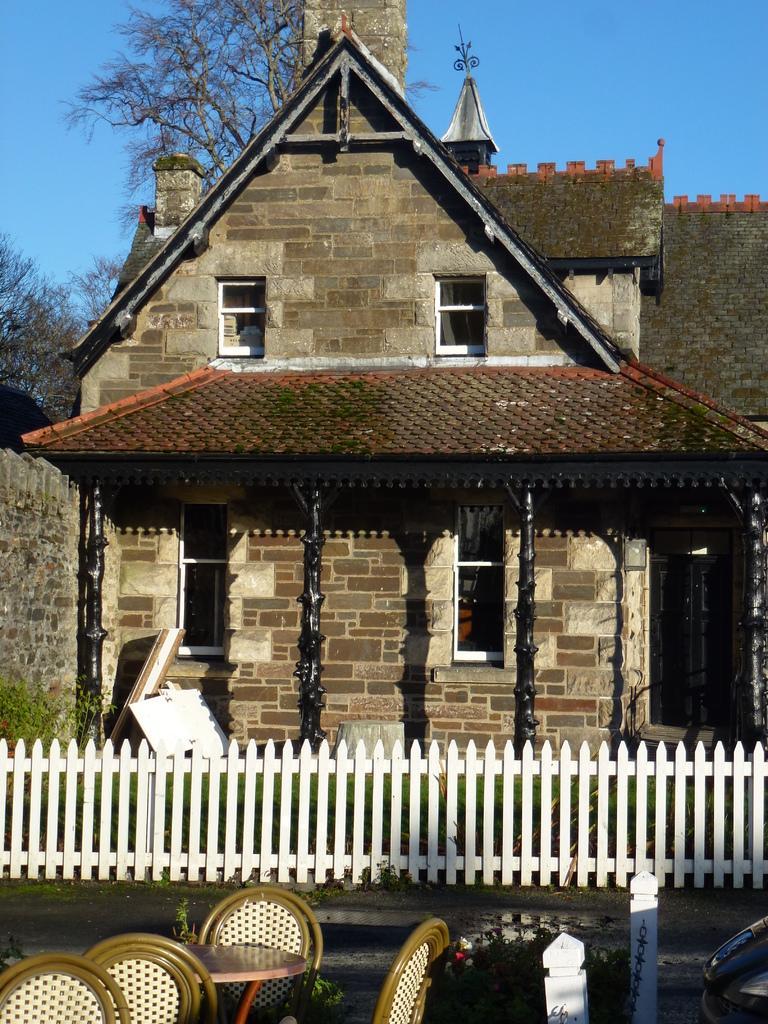In one or two sentences, can you explain what this image depicts? In this image there is a building, railing, boards, pillars, chairs, plant, table, trees, sky and objects. 